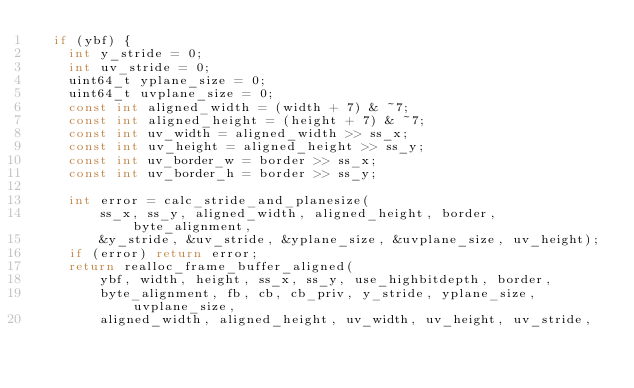<code> <loc_0><loc_0><loc_500><loc_500><_C_>  if (ybf) {
    int y_stride = 0;
    int uv_stride = 0;
    uint64_t yplane_size = 0;
    uint64_t uvplane_size = 0;
    const int aligned_width = (width + 7) & ~7;
    const int aligned_height = (height + 7) & ~7;
    const int uv_width = aligned_width >> ss_x;
    const int uv_height = aligned_height >> ss_y;
    const int uv_border_w = border >> ss_x;
    const int uv_border_h = border >> ss_y;

    int error = calc_stride_and_planesize(
        ss_x, ss_y, aligned_width, aligned_height, border, byte_alignment,
        &y_stride, &uv_stride, &yplane_size, &uvplane_size, uv_height);
    if (error) return error;
    return realloc_frame_buffer_aligned(
        ybf, width, height, ss_x, ss_y, use_highbitdepth, border,
        byte_alignment, fb, cb, cb_priv, y_stride, yplane_size, uvplane_size,
        aligned_width, aligned_height, uv_width, uv_height, uv_stride,</code> 